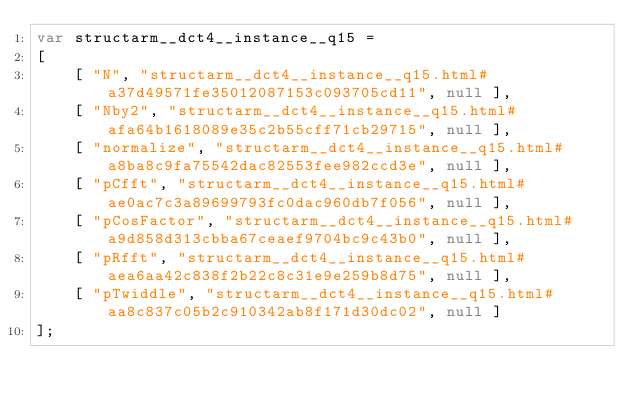Convert code to text. <code><loc_0><loc_0><loc_500><loc_500><_JavaScript_>var structarm__dct4__instance__q15 =
[
    [ "N", "structarm__dct4__instance__q15.html#a37d49571fe35012087153c093705cd11", null ],
    [ "Nby2", "structarm__dct4__instance__q15.html#afa64b1618089e35c2b55cff71cb29715", null ],
    [ "normalize", "structarm__dct4__instance__q15.html#a8ba8c9fa75542dac82553fee982ccd3e", null ],
    [ "pCfft", "structarm__dct4__instance__q15.html#ae0ac7c3a89699793fc0dac960db7f056", null ],
    [ "pCosFactor", "structarm__dct4__instance__q15.html#a9d858d313cbba67ceaef9704bc9c43b0", null ],
    [ "pRfft", "structarm__dct4__instance__q15.html#aea6aa42c838f2b22c8c31e9e259b8d75", null ],
    [ "pTwiddle", "structarm__dct4__instance__q15.html#aa8c837c05b2c910342ab8f171d30dc02", null ]
];</code> 